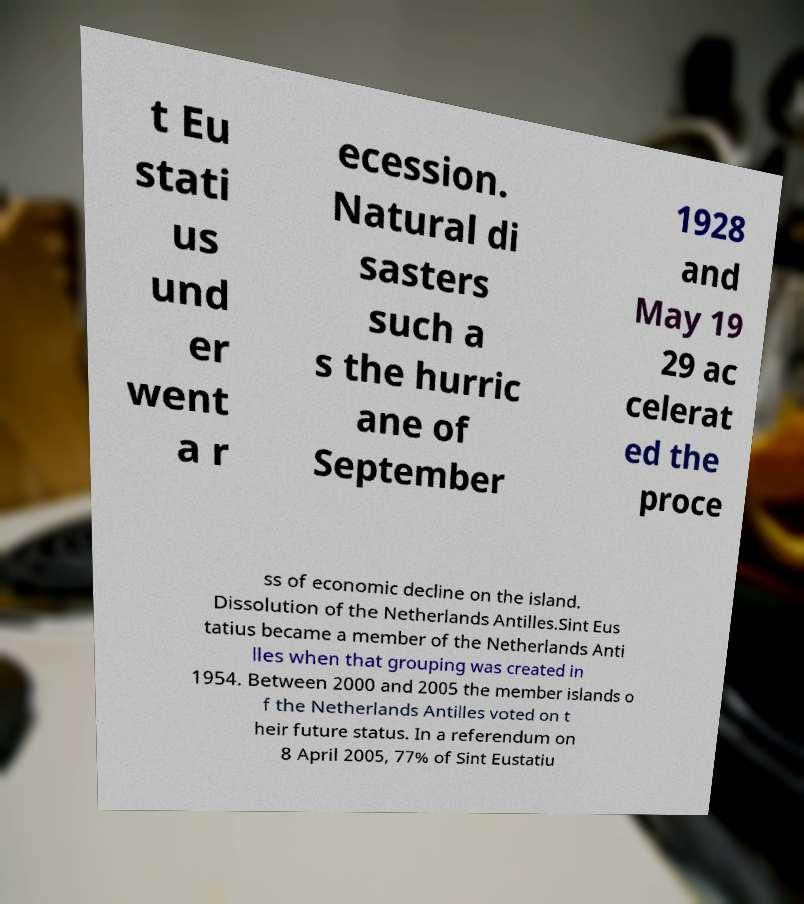Please identify and transcribe the text found in this image. t Eu stati us und er went a r ecession. Natural di sasters such a s the hurric ane of September 1928 and May 19 29 ac celerat ed the proce ss of economic decline on the island. Dissolution of the Netherlands Antilles.Sint Eus tatius became a member of the Netherlands Anti lles when that grouping was created in 1954. Between 2000 and 2005 the member islands o f the Netherlands Antilles voted on t heir future status. In a referendum on 8 April 2005, 77% of Sint Eustatiu 